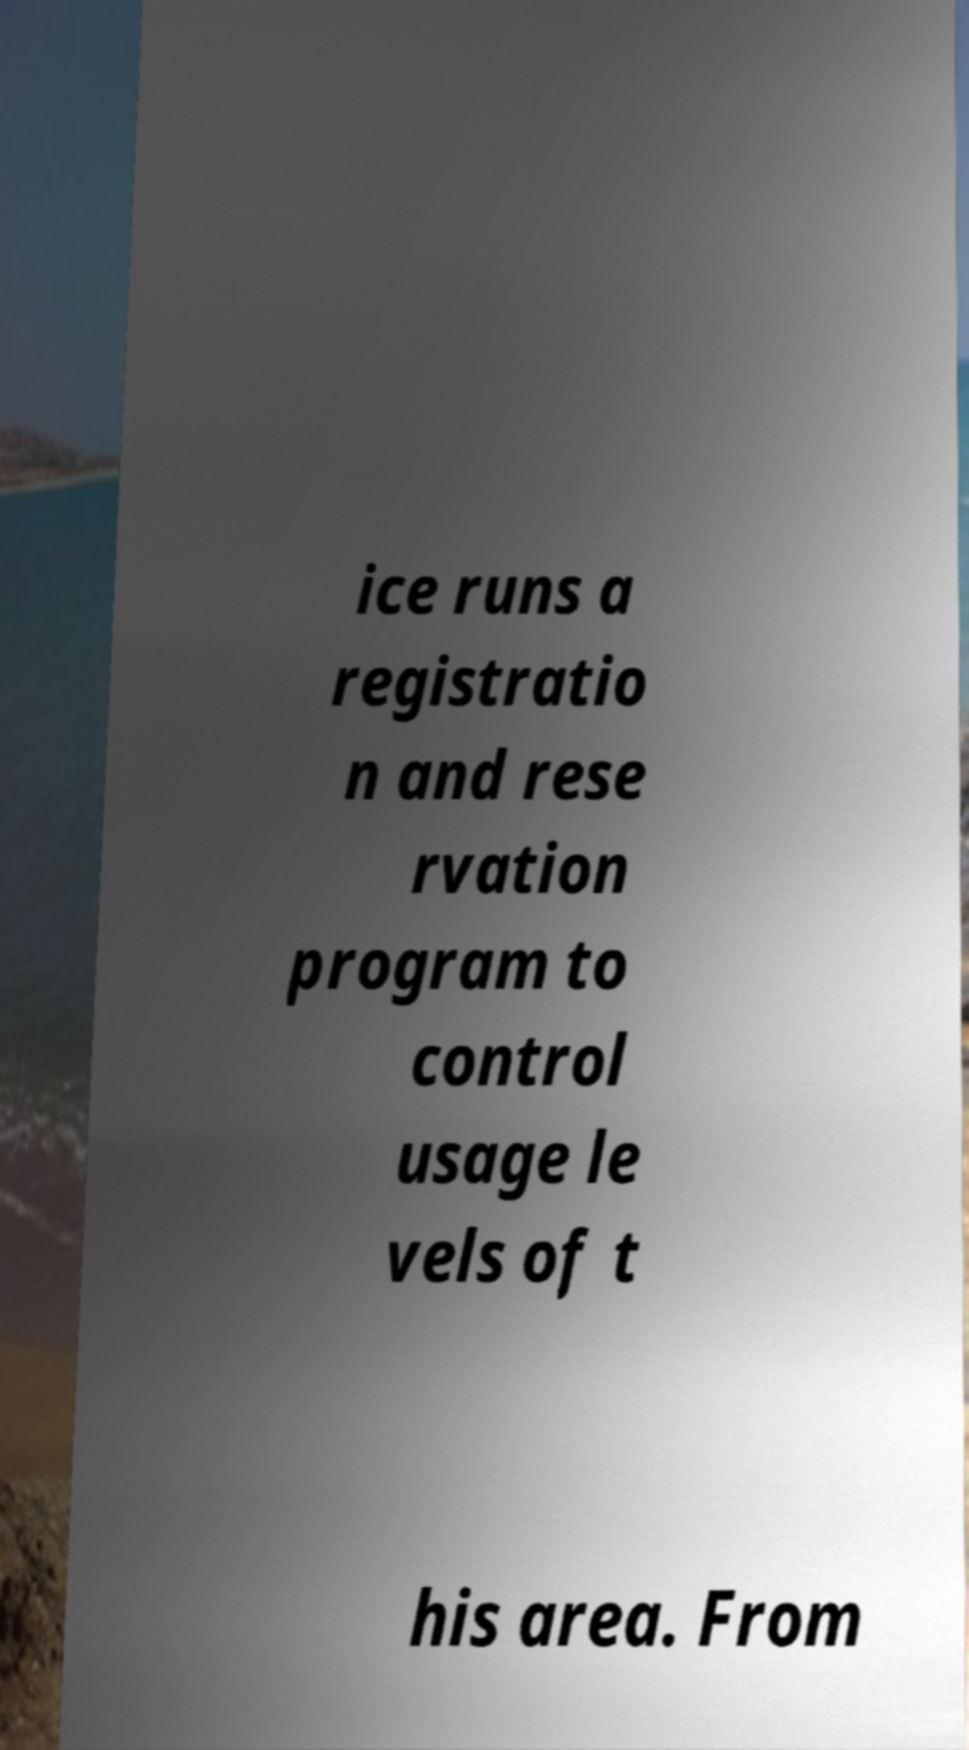Please read and relay the text visible in this image. What does it say? ice runs a registratio n and rese rvation program to control usage le vels of t his area. From 